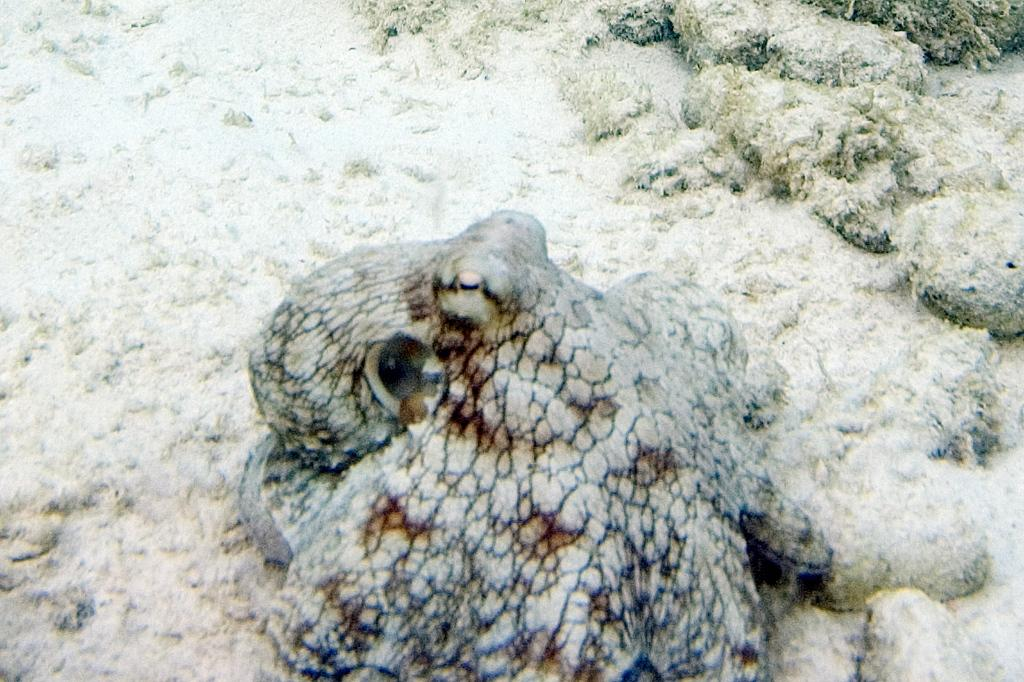What type of animal can be seen at the bottom of the image? There is an aquatic animal present at the bottom of the image. What color is the smashed meal on the floor in the image? There is no smashed meal on the floor in the image. The image only features an aquatic animal at the bottom. 